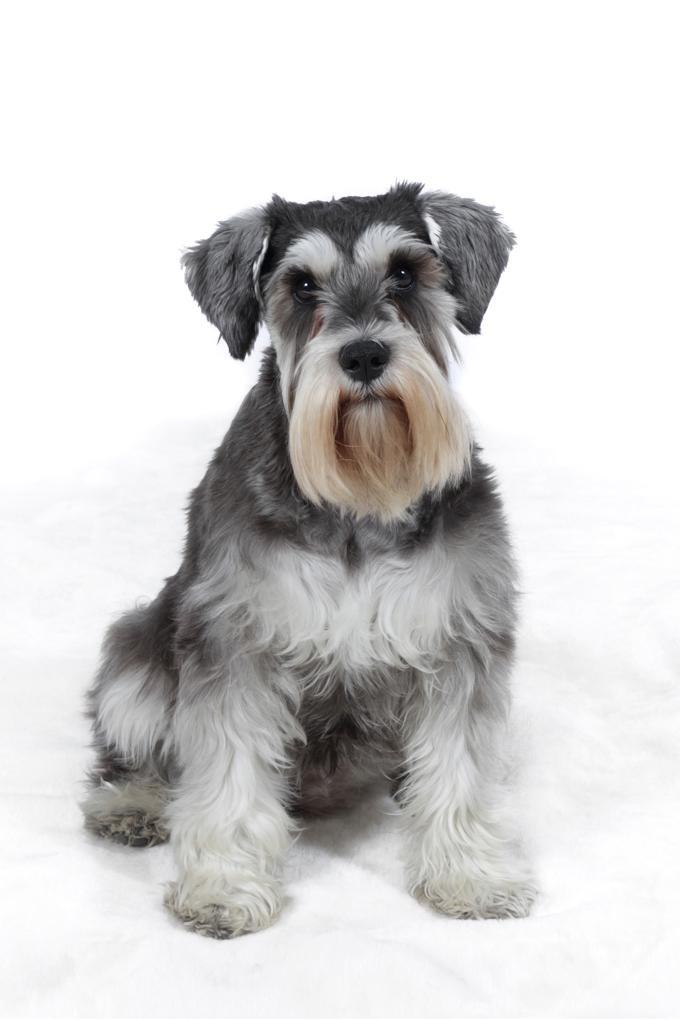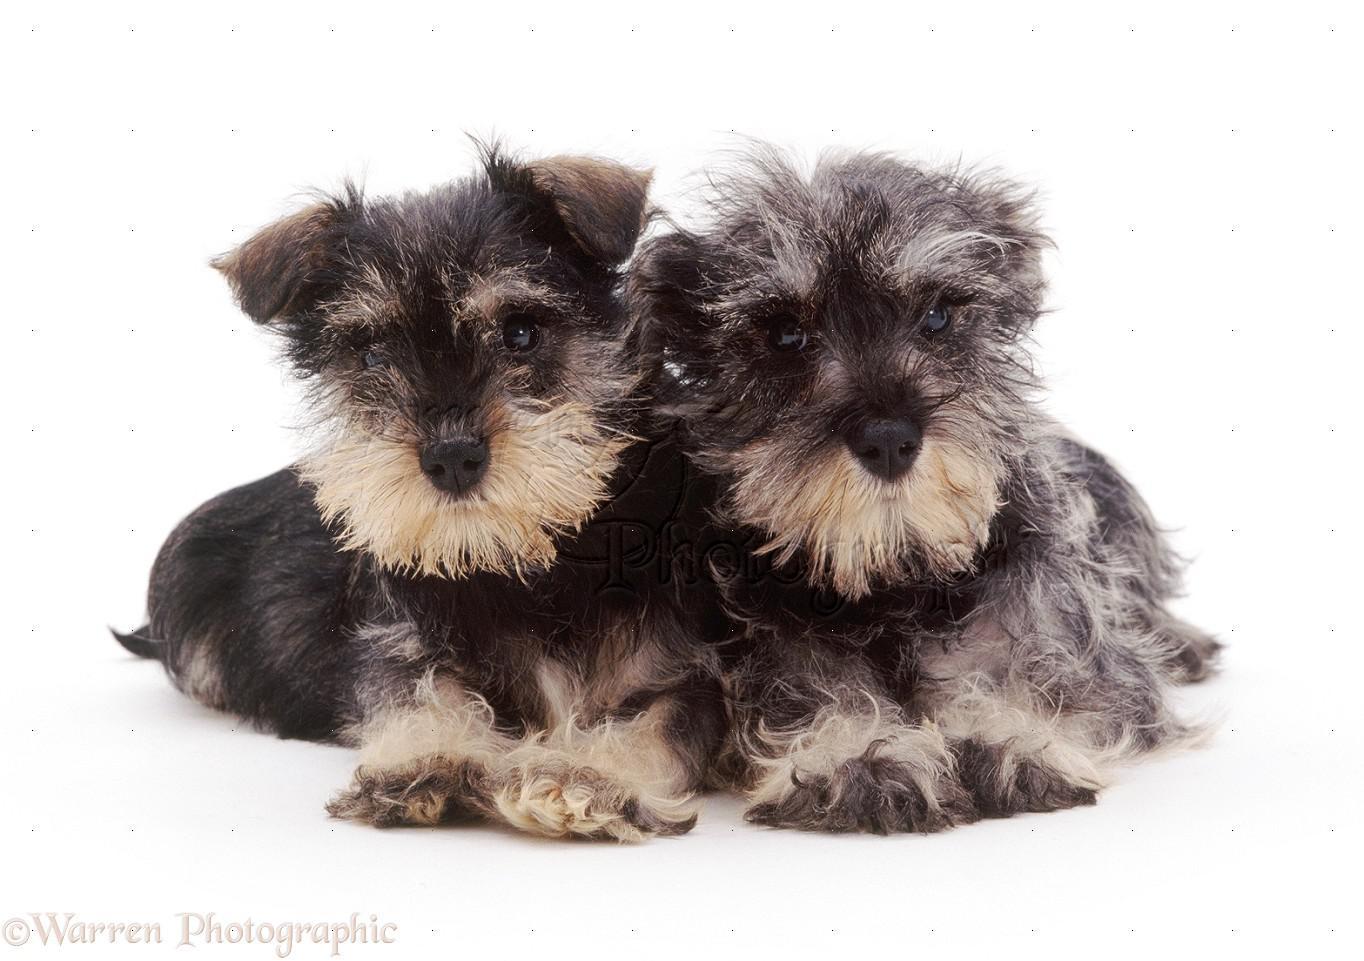The first image is the image on the left, the second image is the image on the right. Considering the images on both sides, is "There are two dogs in one of the images." valid? Answer yes or no. Yes. 